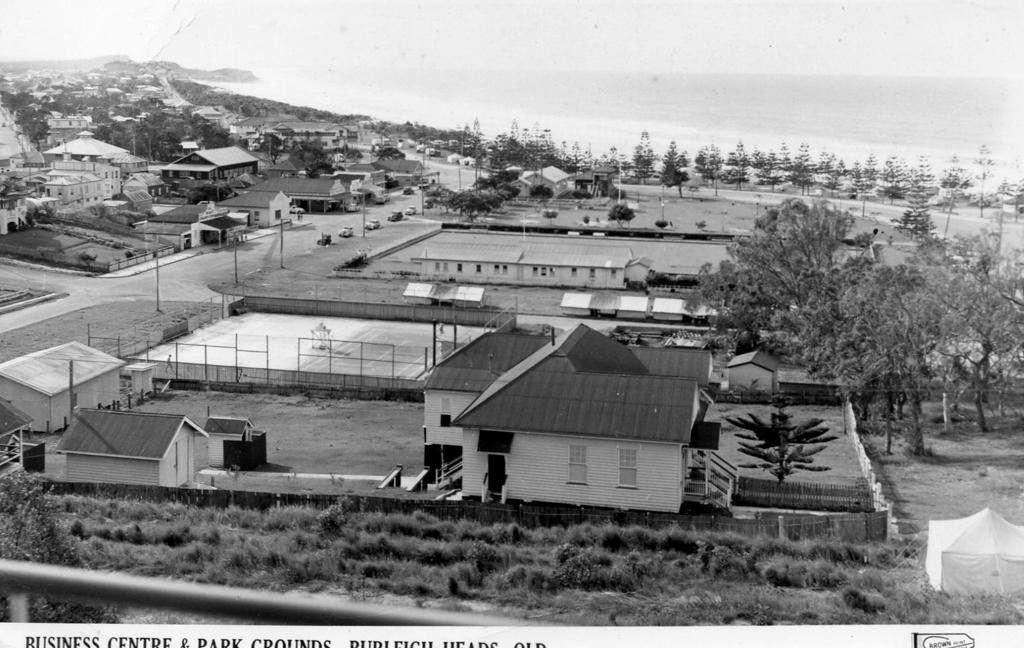What is the color scheme of the image? The image is black and white. What type of structures can be seen in the image? There are buildings, sheds, and tents in the image. What type of vegetation is present in the image? There are trees in the image. What other objects can be seen in the image? There are poles, fences, and vehicles on the road in the image. What is written at the bottom of the image? There is text at the bottom of the image. What symbol is present at the bottom of the image? There is a logo at the bottom of the image. How many matches are being used to light the yam in the image? There are no matches or yams present in the image. What type of army is depicted in the image? There is no army depicted in the image; it features various structures, objects, and text. 